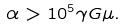Convert formula to latex. <formula><loc_0><loc_0><loc_500><loc_500>\alpha > 1 0 ^ { 5 } \gamma G \mu .</formula> 